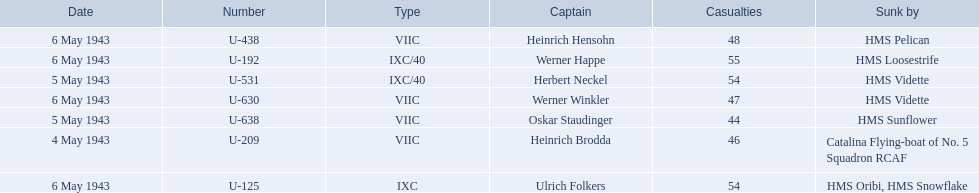What boats were lost on may 5? U-638, U-531. Who were the captains of those boats? Oskar Staudinger, Herbert Neckel. Which captain was not oskar staudinger? Herbert Neckel. 